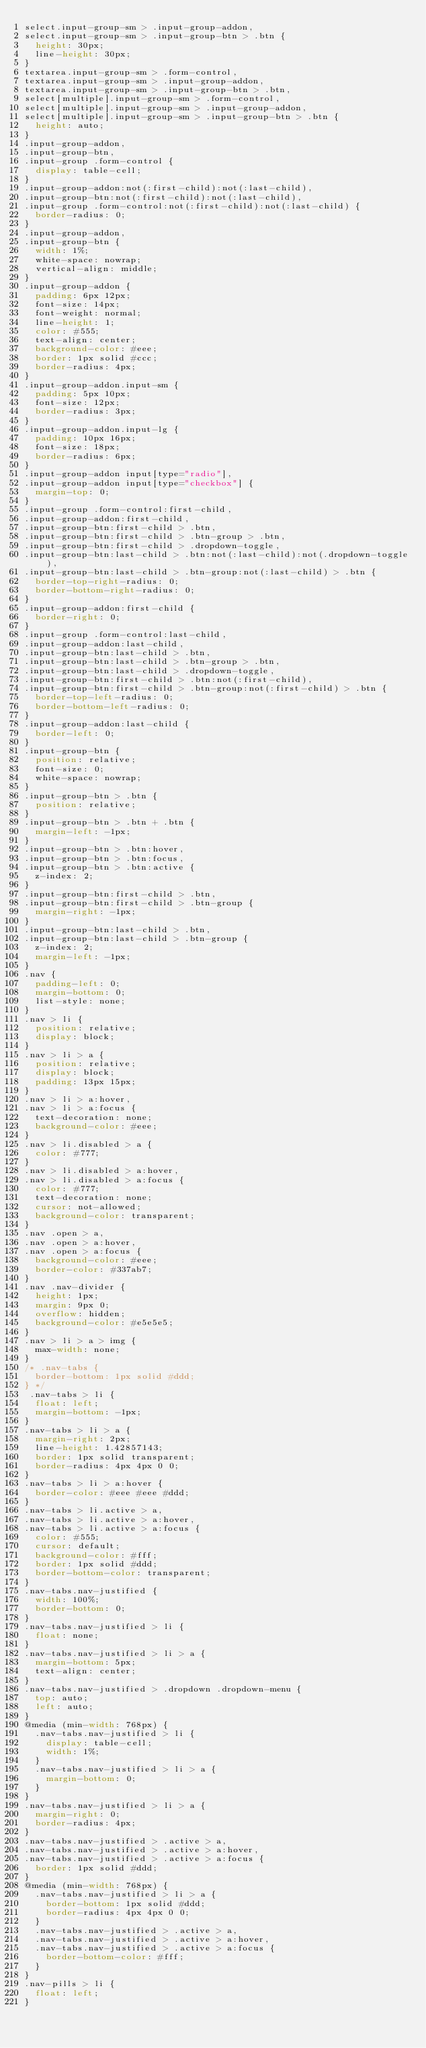<code> <loc_0><loc_0><loc_500><loc_500><_CSS_>select.input-group-sm > .input-group-addon,
select.input-group-sm > .input-group-btn > .btn {
  height: 30px;
  line-height: 30px;
}
textarea.input-group-sm > .form-control,
textarea.input-group-sm > .input-group-addon,
textarea.input-group-sm > .input-group-btn > .btn,
select[multiple].input-group-sm > .form-control,
select[multiple].input-group-sm > .input-group-addon,
select[multiple].input-group-sm > .input-group-btn > .btn {
  height: auto;
}
.input-group-addon,
.input-group-btn,
.input-group .form-control {
  display: table-cell;
}
.input-group-addon:not(:first-child):not(:last-child),
.input-group-btn:not(:first-child):not(:last-child),
.input-group .form-control:not(:first-child):not(:last-child) {
  border-radius: 0;
}
.input-group-addon,
.input-group-btn {
  width: 1%;
  white-space: nowrap;
  vertical-align: middle;
}
.input-group-addon {
  padding: 6px 12px;
  font-size: 14px;
  font-weight: normal;
  line-height: 1;
  color: #555;
  text-align: center;
  background-color: #eee;
  border: 1px solid #ccc;
  border-radius: 4px;
}
.input-group-addon.input-sm {
  padding: 5px 10px;
  font-size: 12px;
  border-radius: 3px;
}
.input-group-addon.input-lg {
  padding: 10px 16px;
  font-size: 18px;
  border-radius: 6px;
}
.input-group-addon input[type="radio"],
.input-group-addon input[type="checkbox"] {
  margin-top: 0;
}
.input-group .form-control:first-child,
.input-group-addon:first-child,
.input-group-btn:first-child > .btn,
.input-group-btn:first-child > .btn-group > .btn,
.input-group-btn:first-child > .dropdown-toggle,
.input-group-btn:last-child > .btn:not(:last-child):not(.dropdown-toggle),
.input-group-btn:last-child > .btn-group:not(:last-child) > .btn {
  border-top-right-radius: 0;
  border-bottom-right-radius: 0;
}
.input-group-addon:first-child {
  border-right: 0;
}
.input-group .form-control:last-child,
.input-group-addon:last-child,
.input-group-btn:last-child > .btn,
.input-group-btn:last-child > .btn-group > .btn,
.input-group-btn:last-child > .dropdown-toggle,
.input-group-btn:first-child > .btn:not(:first-child),
.input-group-btn:first-child > .btn-group:not(:first-child) > .btn {
  border-top-left-radius: 0;
  border-bottom-left-radius: 0;
}
.input-group-addon:last-child {
  border-left: 0;
}
.input-group-btn {
  position: relative;
  font-size: 0;
  white-space: nowrap;
}
.input-group-btn > .btn {
  position: relative;
}
.input-group-btn > .btn + .btn {
  margin-left: -1px;
}
.input-group-btn > .btn:hover,
.input-group-btn > .btn:focus,
.input-group-btn > .btn:active {
  z-index: 2;
}
.input-group-btn:first-child > .btn,
.input-group-btn:first-child > .btn-group {
  margin-right: -1px;
}
.input-group-btn:last-child > .btn,
.input-group-btn:last-child > .btn-group {
  z-index: 2;
  margin-left: -1px;
}
.nav {
  padding-left: 0;
  margin-bottom: 0;
  list-style: none;
}
.nav > li {
  position: relative;
  display: block;
}
.nav > li > a {
  position: relative;
  display: block;
  padding: 13px 15px;
}
.nav > li > a:hover,
.nav > li > a:focus {
  text-decoration: none;
  background-color: #eee;
}
.nav > li.disabled > a {
  color: #777;
}
.nav > li.disabled > a:hover,
.nav > li.disabled > a:focus {
  color: #777;
  text-decoration: none;
  cursor: not-allowed;
  background-color: transparent;
}
.nav .open > a,
.nav .open > a:hover,
.nav .open > a:focus {
  background-color: #eee;
  border-color: #337ab7;
}
.nav .nav-divider {
  height: 1px;
  margin: 9px 0;
  overflow: hidden;
  background-color: #e5e5e5;
}
.nav > li > a > img {
  max-width: none;
}
/* .nav-tabs {
  border-bottom: 1px solid #ddd;
} */
 .nav-tabs > li {
  float: left;
  margin-bottom: -1px;
} 
.nav-tabs > li > a {
  margin-right: 2px;
  line-height: 1.42857143;
  border: 1px solid transparent;
  border-radius: 4px 4px 0 0;
}
.nav-tabs > li > a:hover {
  border-color: #eee #eee #ddd;
}
.nav-tabs > li.active > a,
.nav-tabs > li.active > a:hover,
.nav-tabs > li.active > a:focus {
  color: #555;
  cursor: default;
  background-color: #fff;
  border: 1px solid #ddd;
  border-bottom-color: transparent;
}
.nav-tabs.nav-justified {
  width: 100%;
  border-bottom: 0;
}
.nav-tabs.nav-justified > li {
  float: none;
}
.nav-tabs.nav-justified > li > a {
  margin-bottom: 5px;
  text-align: center;
}
.nav-tabs.nav-justified > .dropdown .dropdown-menu {
  top: auto;
  left: auto;
}
@media (min-width: 768px) {
  .nav-tabs.nav-justified > li {
    display: table-cell;
    width: 1%;
  }
  .nav-tabs.nav-justified > li > a {
    margin-bottom: 0;
  }
}
.nav-tabs.nav-justified > li > a {
  margin-right: 0;
  border-radius: 4px;
}
.nav-tabs.nav-justified > .active > a,
.nav-tabs.nav-justified > .active > a:hover,
.nav-tabs.nav-justified > .active > a:focus {
  border: 1px solid #ddd;
}
@media (min-width: 768px) {
  .nav-tabs.nav-justified > li > a {
    border-bottom: 1px solid #ddd;
    border-radius: 4px 4px 0 0;
  }
  .nav-tabs.nav-justified > .active > a,
  .nav-tabs.nav-justified > .active > a:hover,
  .nav-tabs.nav-justified > .active > a:focus {
    border-bottom-color: #fff;
  }
}
.nav-pills > li {
  float: left;
}</code> 